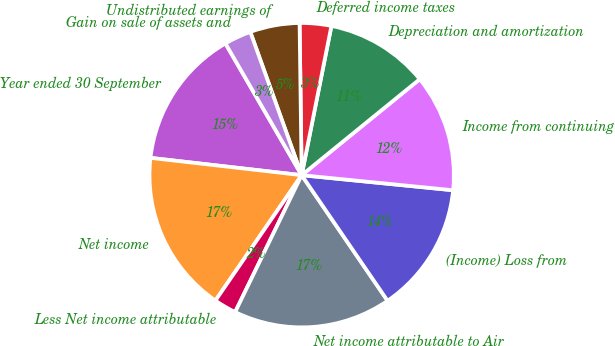Convert chart. <chart><loc_0><loc_0><loc_500><loc_500><pie_chart><fcel>Year ended 30 September<fcel>Net income<fcel>Less Net income attributable<fcel>Net income attributable to Air<fcel>(Income) Loss from<fcel>Income from continuing<fcel>Depreciation and amortization<fcel>Deferred income taxes<fcel>Undistributed earnings of<fcel>Gain on sale of assets and<nl><fcel>14.83%<fcel>17.22%<fcel>2.39%<fcel>16.74%<fcel>13.87%<fcel>12.44%<fcel>11.0%<fcel>3.35%<fcel>5.26%<fcel>2.87%<nl></chart> 